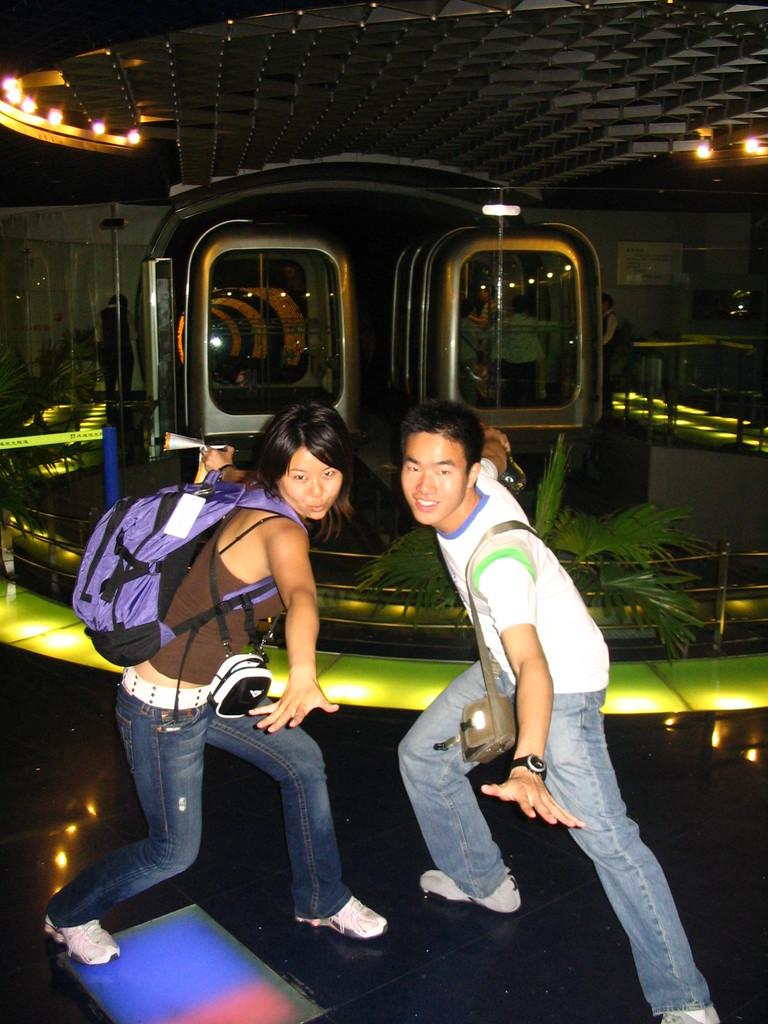What are the people in the front of the image doing? The persons in the front of the image are standing and posing. What can be seen in the background of the image? There are trains and persons visible in the background of the image. What is located at the top of the image? There are lights visible in the top of the image. What type of jewel is the cat wearing in the image? There is no cat or jewel present in the image. 